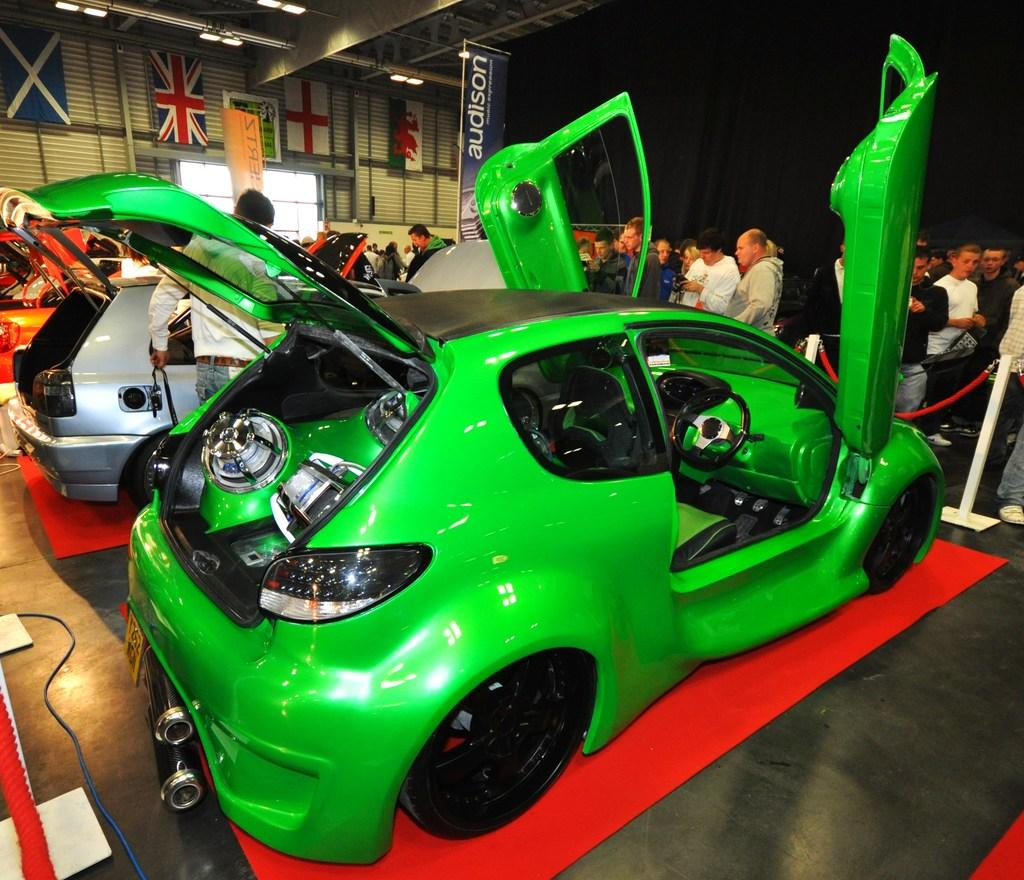What is the main subject of the image? The main subject of the image is two cars on a red carpet. What are the people near the cars doing? The people standing near the cars are looking at the cars. What can be seen in the background of the image? There are flags and a poster visible in the image. What type of cream is being used to develop the cars in the image? There is no cream or development process depicted in the image; it simply shows two cars on a red carpet with people looking at them. 